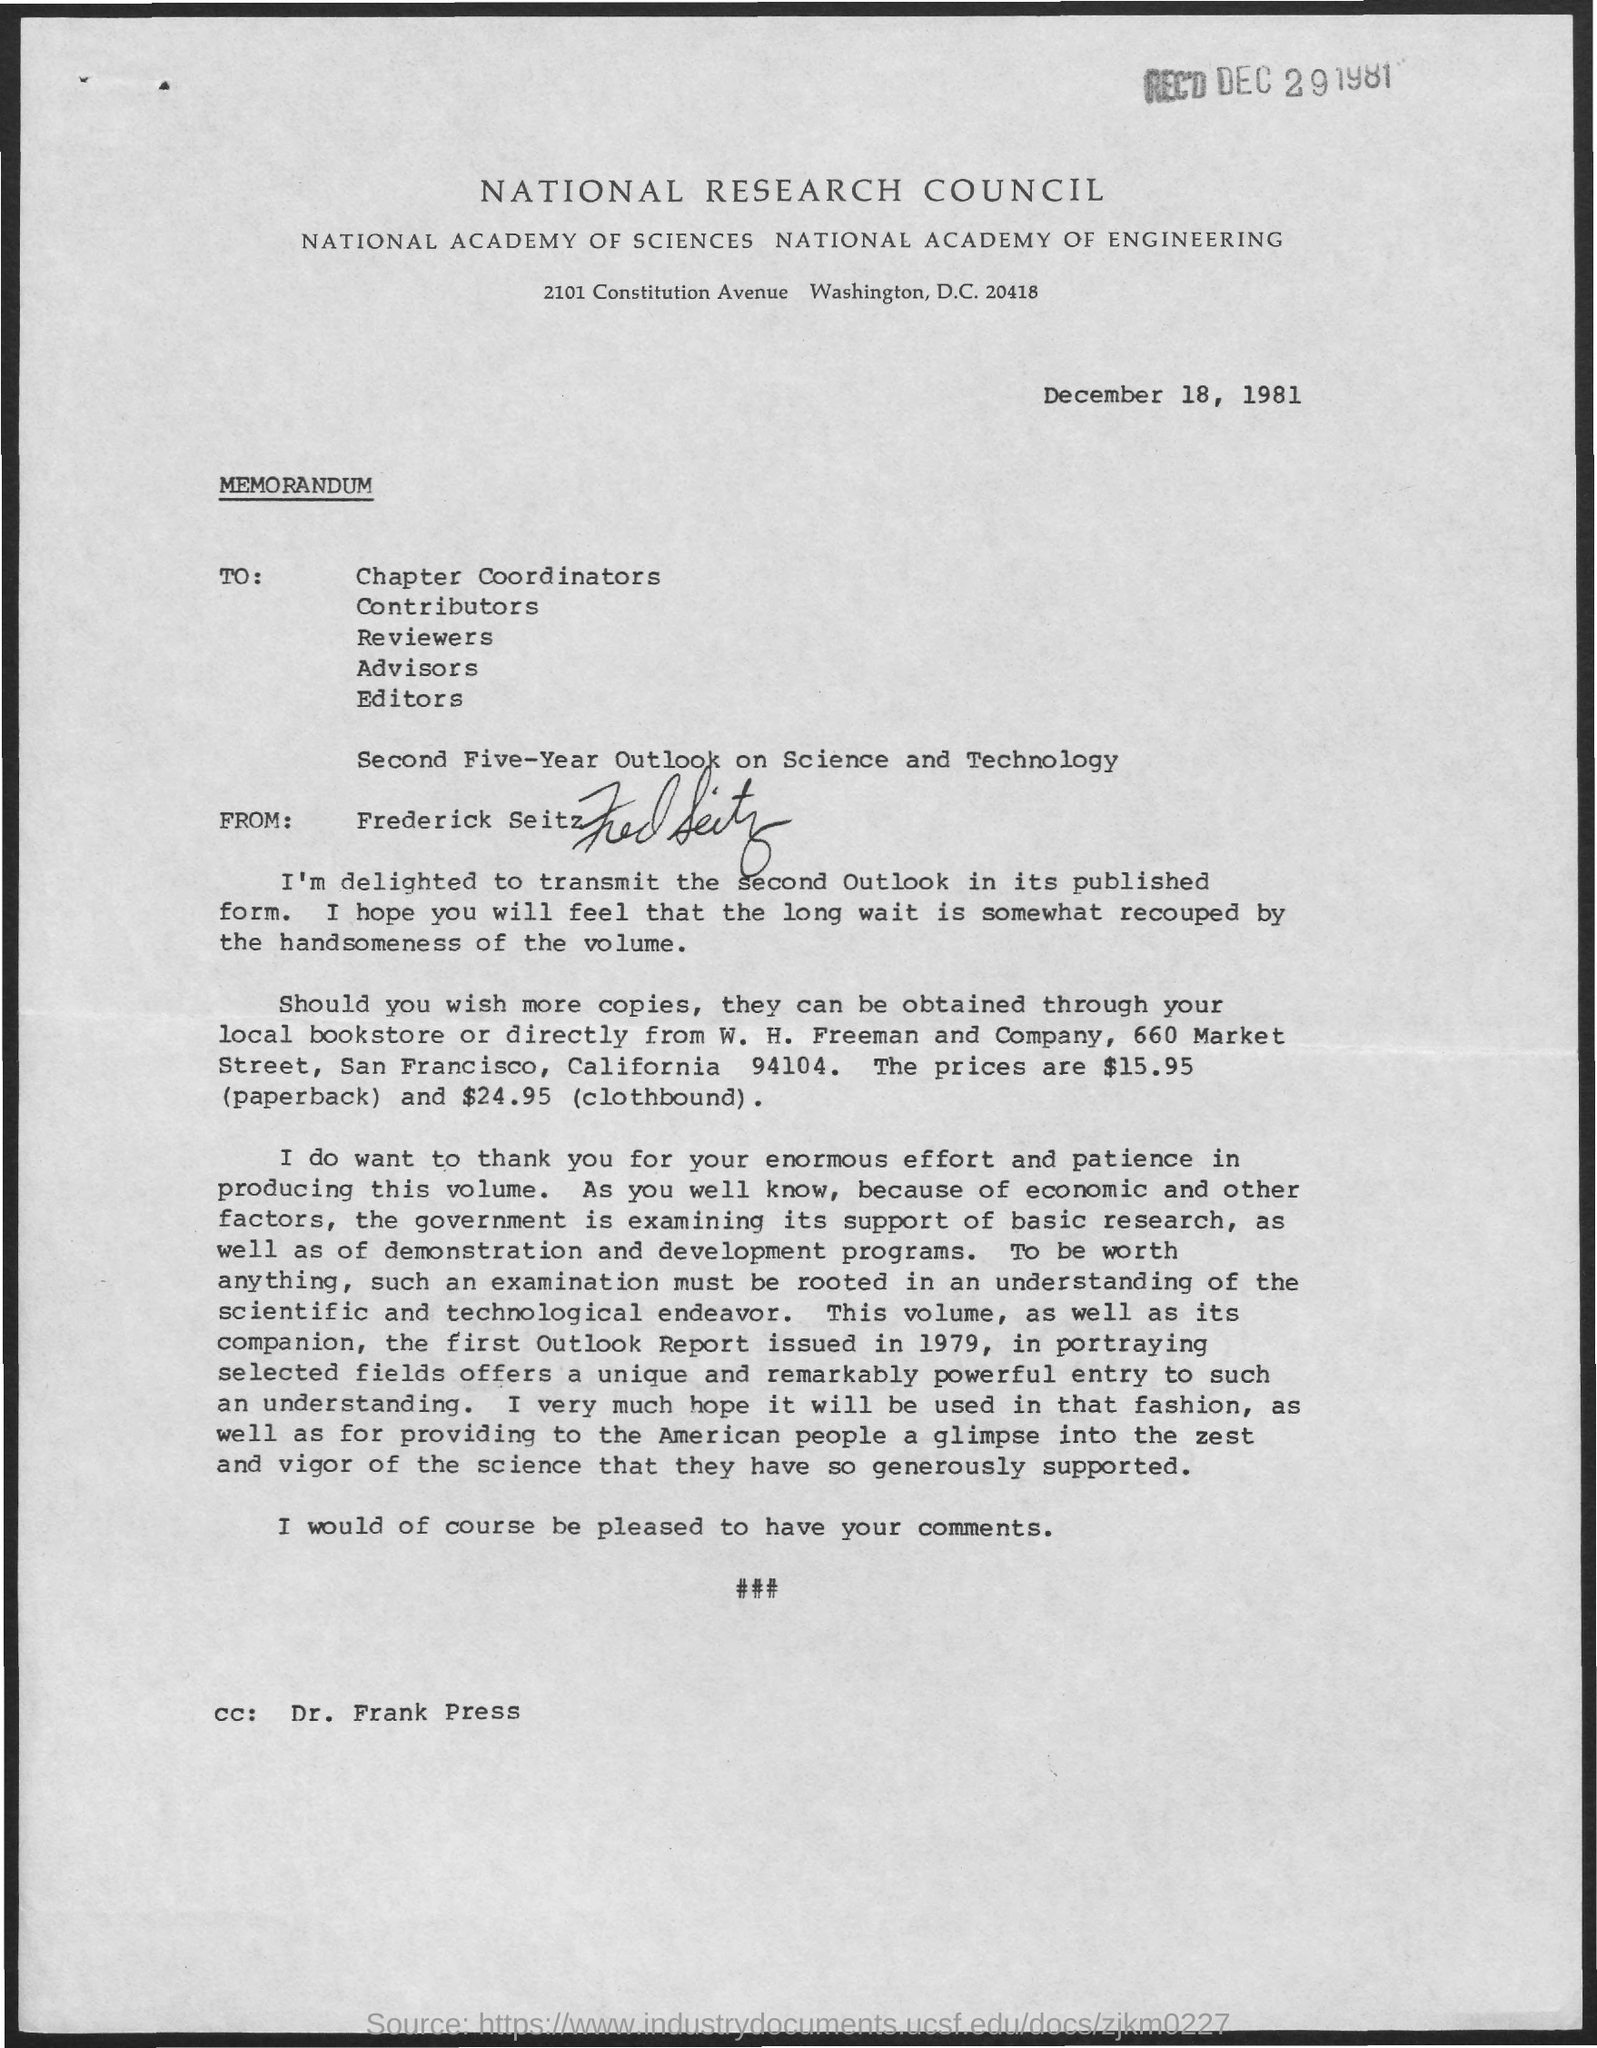Indicate a few pertinent items in this graphic. This document is a memorandum. The memorandum's cc list includes Dr. Frank Press. The issued date of this memorandum is December 18, 1981. The sender of this memorandum is Frederick Seitz. 